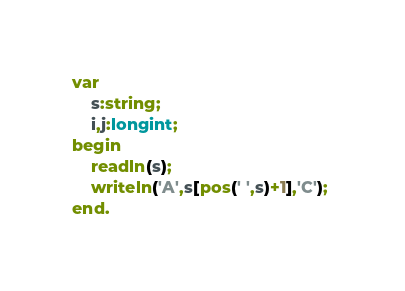Convert code to text. <code><loc_0><loc_0><loc_500><loc_500><_Pascal_>var
    s:string;
    i,j:longint;
begin
    readln(s);
    writeln('A',s[pos(' ',s)+1],'C'); 
end.  </code> 